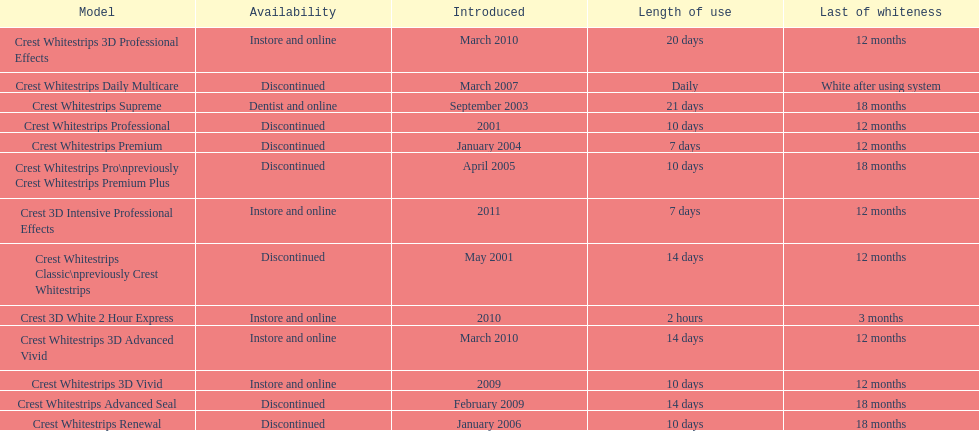How many products have been discontinued? 7. 